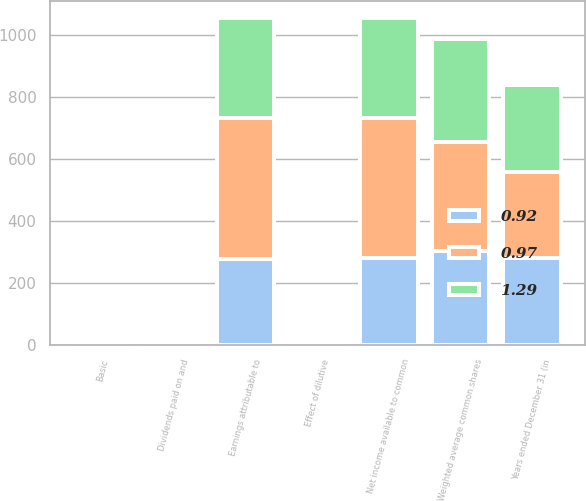Convert chart. <chart><loc_0><loc_0><loc_500><loc_500><stacked_bar_chart><ecel><fcel>Years ended December 31 (in<fcel>Net income available to common<fcel>Dividends paid on and<fcel>Earnings attributable to<fcel>Weighted average common shares<fcel>Effect of dilutive<fcel>Basic<nl><fcel>0.97<fcel>279.2<fcel>454<fcel>0.2<fcel>453.8<fcel>351.7<fcel>3.6<fcel>1.3<nl><fcel>1.29<fcel>279.2<fcel>323.1<fcel>0.5<fcel>322.6<fcel>332.9<fcel>2.6<fcel>0.98<nl><fcel>0.92<fcel>279.2<fcel>279.2<fcel>0.9<fcel>278.3<fcel>304<fcel>0.9<fcel>0.92<nl></chart> 